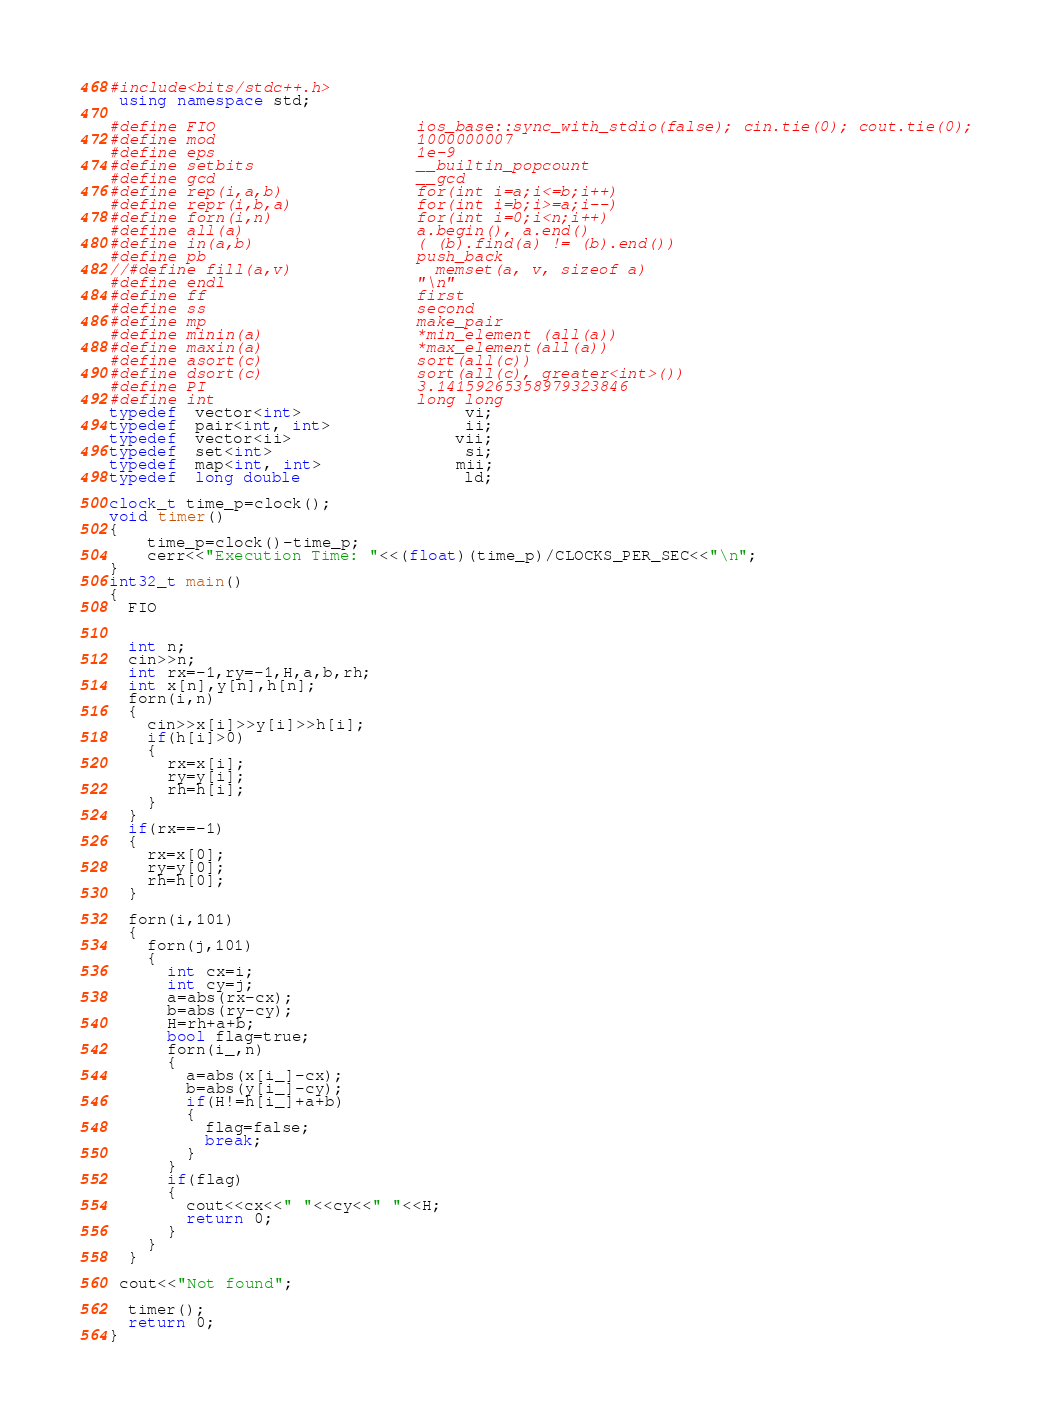<code> <loc_0><loc_0><loc_500><loc_500><_C++_>#include<bits/stdc++.h>
 using namespace std;

#define FIO                     ios_base::sync_with_stdio(false); cin.tie(0); cout.tie(0);
#define mod                     1000000007
#define eps                     1e-9
#define setbits                 __builtin_popcount
#define gcd                     __gcd
#define rep(i,a,b)              for(int i=a;i<=b;i++)
#define repr(i,b,a)             for(int i=b;i>=a;i--)
#define forn(i,n)               for(int i=0;i<n;i++)
#define all(a)                  a.begin(), a.end()
#define in(a,b)                 ( (b).find(a) != (b).end())
#define pb                      push_back
//#define fill(a,v)               memset(a, v, sizeof a)
#define endl                    "\n"
#define ff                      first
#define ss                      second
#define mp                      make_pair
#define minin(a)                *min_element (all(a))
#define maxin(a)                *max_element(all(a))
#define asort(c)                sort(all(c))
#define dsort(c)                sort(all(c), greater<int>()) 
#define PI                      3.14159265358979323846
#define int                     long long
typedef  vector<int>                 vi;
typedef  pair<int, int>              ii;
typedef  vector<ii>                 vii;
typedef  set<int>                    si;
typedef  map<int, int>              mii;
typedef  long double                 ld;

clock_t time_p=clock();
void timer()
{
    time_p=clock()-time_p;
    cerr<<"Execution Time: "<<(float)(time_p)/CLOCKS_PER_SEC<<"\n";
}
int32_t main()
{
  FIO
  
 
  int n;
  cin>>n;
  int rx=-1,ry=-1,H,a,b,rh;
  int x[n],y[n],h[n];
  forn(i,n)
  {
    cin>>x[i]>>y[i]>>h[i];
    if(h[i]>0)
    {
      rx=x[i];
      ry=y[i];
      rh=h[i];
    }
  }
  if(rx==-1)
  {
    rx=x[0];
    ry=y[0];
    rh=h[0];
  }
  
  forn(i,101)
  {
    forn(j,101)
    {
      int cx=i;
      int cy=j;
      a=abs(rx-cx);
      b=abs(ry-cy); 
      H=rh+a+b;
      bool flag=true;
      forn(i_,n)
      {
        a=abs(x[i_]-cx);
        b=abs(y[i_]-cy); 
        if(H!=h[i_]+a+b)
        {
          flag=false;
          break;
        }
      }
      if(flag)
      {
        cout<<cx<<" "<<cy<<" "<<H;
        return 0;
      }
    }
  }
 
 cout<<"Not found";

  timer();
  return 0;
}  </code> 